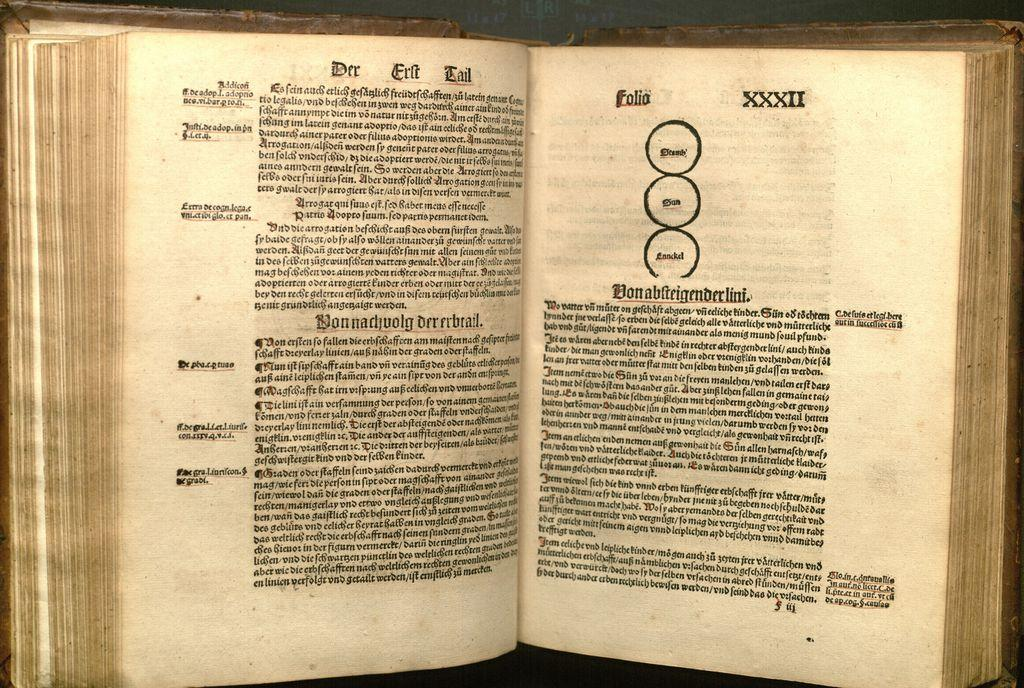<image>
Provide a brief description of the given image. XXXII is the roman numeral written at the top of the second page in this book. 